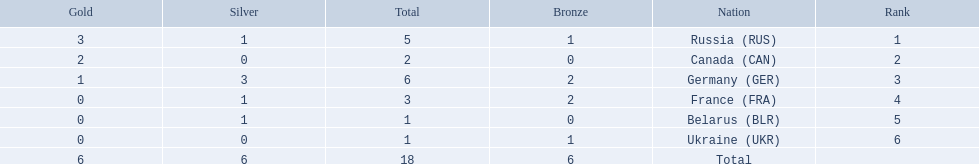Which countries had one or more gold medals? Russia (RUS), Canada (CAN), Germany (GER). Of these countries, which had at least one silver medal? Russia (RUS), Germany (GER). Of the remaining countries, who had more medals overall? Germany (GER). 